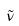Convert formula to latex. <formula><loc_0><loc_0><loc_500><loc_500>\tilde { \nu }</formula> 